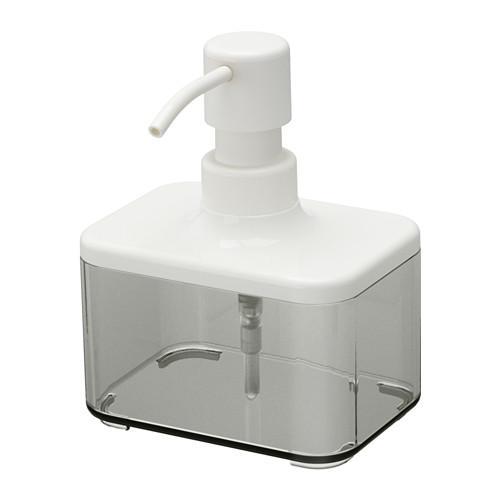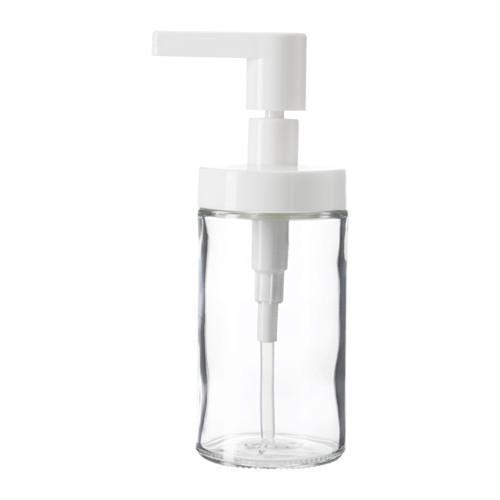The first image is the image on the left, the second image is the image on the right. Given the left and right images, does the statement "Both dispensers have silver colored nozzles." hold true? Answer yes or no. No. The first image is the image on the left, the second image is the image on the right. Examine the images to the left and right. Is the description "The left and right image contains the same number of sink soap dispensers with one sold bottle." accurate? Answer yes or no. No. 